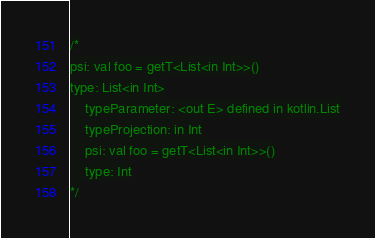<code> <loc_0><loc_0><loc_500><loc_500><_Kotlin_>/*
psi: val foo = getT<List<in Int>>()
type: List<in Int>
    typeParameter: <out E> defined in kotlin.List
    typeProjection: in Int
    psi: val foo = getT<List<in Int>>()
    type: Int
*/</code> 